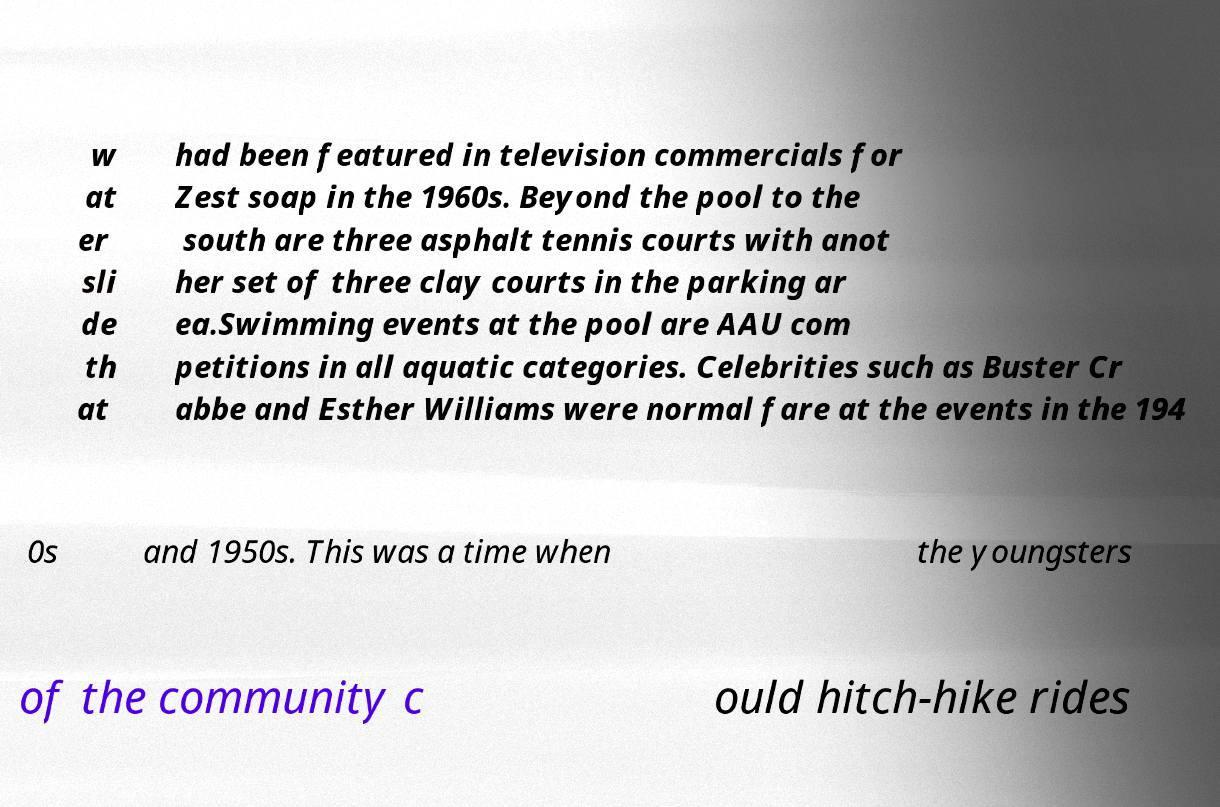Could you assist in decoding the text presented in this image and type it out clearly? w at er sli de th at had been featured in television commercials for Zest soap in the 1960s. Beyond the pool to the south are three asphalt tennis courts with anot her set of three clay courts in the parking ar ea.Swimming events at the pool are AAU com petitions in all aquatic categories. Celebrities such as Buster Cr abbe and Esther Williams were normal fare at the events in the 194 0s and 1950s. This was a time when the youngsters of the community c ould hitch-hike rides 